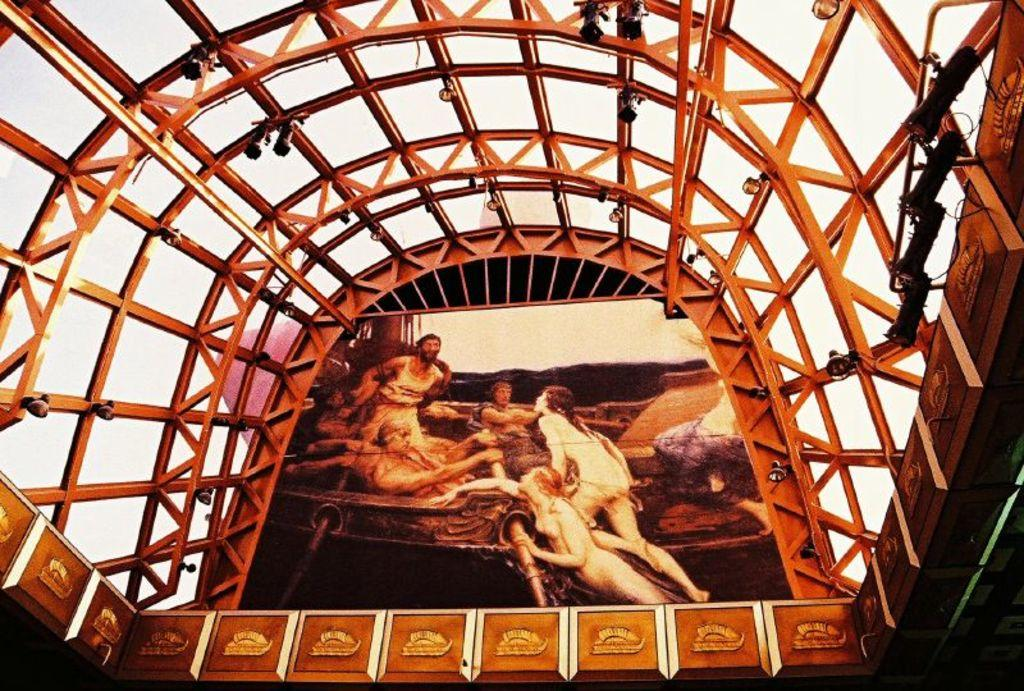What type of objects can be seen in the image? There are iron rods in the image. What else is present in the image besides the iron rods? There is a banner or poster and show lights visible in the image. What can be seen in the background of the image? The sky is visible in the background of the image. How many clams are sitting on the iron rods in the image? There are no clams present in the image; it features iron rods, a banner or poster, show lights, and a visible sky. What type of crow is perched on the banner in the image? There is no crow present in the image; it only features iron rods, a banner or poster, show lights, and a visible sky. 